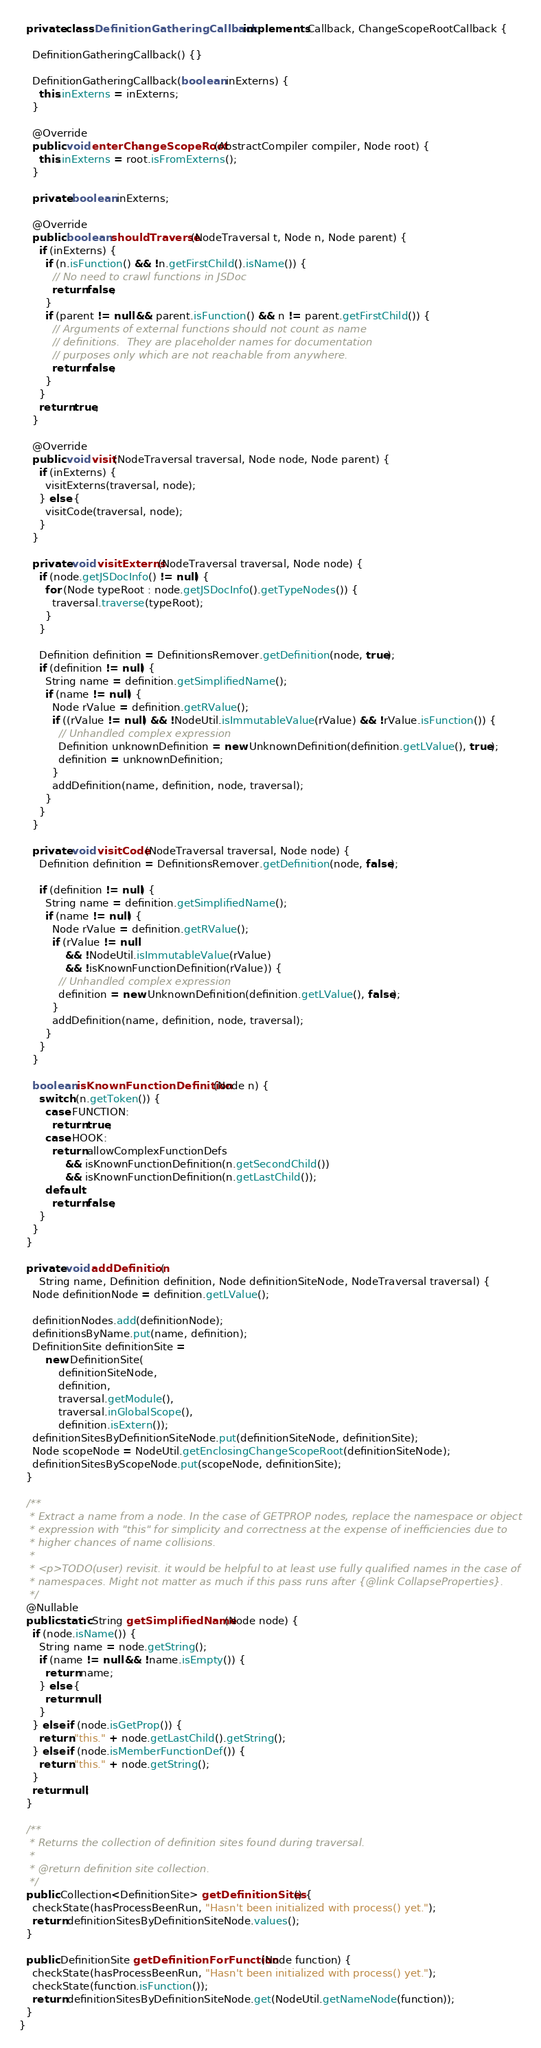Convert code to text. <code><loc_0><loc_0><loc_500><loc_500><_Java_>
  private class DefinitionGatheringCallback implements Callback, ChangeScopeRootCallback {

    DefinitionGatheringCallback() {}

    DefinitionGatheringCallback(boolean inExterns) {
      this.inExterns = inExterns;
    }

    @Override
    public void enterChangeScopeRoot(AbstractCompiler compiler, Node root) {
      this.inExterns = root.isFromExterns();
    }

    private boolean inExterns;

    @Override
    public boolean shouldTraverse(NodeTraversal t, Node n, Node parent) {
      if (inExterns) {
        if (n.isFunction() && !n.getFirstChild().isName()) {
          // No need to crawl functions in JSDoc
          return false;
        }
        if (parent != null && parent.isFunction() && n != parent.getFirstChild()) {
          // Arguments of external functions should not count as name
          // definitions.  They are placeholder names for documentation
          // purposes only which are not reachable from anywhere.
          return false;
        }
      }
      return true;
    }

    @Override
    public void visit(NodeTraversal traversal, Node node, Node parent) {
      if (inExterns) {
        visitExterns(traversal, node);
      } else {
        visitCode(traversal, node);
      }
    }

    private void visitExterns(NodeTraversal traversal, Node node) {
      if (node.getJSDocInfo() != null) {
        for (Node typeRoot : node.getJSDocInfo().getTypeNodes()) {
          traversal.traverse(typeRoot);
        }
      }

      Definition definition = DefinitionsRemover.getDefinition(node, true);
      if (definition != null) {
        String name = definition.getSimplifiedName();
        if (name != null) {
          Node rValue = definition.getRValue();
          if ((rValue != null) && !NodeUtil.isImmutableValue(rValue) && !rValue.isFunction()) {
            // Unhandled complex expression
            Definition unknownDefinition = new UnknownDefinition(definition.getLValue(), true);
            definition = unknownDefinition;
          }
          addDefinition(name, definition, node, traversal);
        }
      }
    }

    private void visitCode(NodeTraversal traversal, Node node) {
      Definition definition = DefinitionsRemover.getDefinition(node, false);

      if (definition != null) {
        String name = definition.getSimplifiedName();
        if (name != null) {
          Node rValue = definition.getRValue();
          if (rValue != null
              && !NodeUtil.isImmutableValue(rValue)
              && !isKnownFunctionDefinition(rValue)) {
            // Unhandled complex expression
            definition = new UnknownDefinition(definition.getLValue(), false);
          }
          addDefinition(name, definition, node, traversal);
        }
      }
    }

    boolean isKnownFunctionDefinition(Node n) {
      switch (n.getToken()) {
        case FUNCTION:
          return true;
        case HOOK:
          return allowComplexFunctionDefs
              && isKnownFunctionDefinition(n.getSecondChild())
              && isKnownFunctionDefinition(n.getLastChild());
        default:
          return false;
      }
    }
  }

  private void addDefinition(
      String name, Definition definition, Node definitionSiteNode, NodeTraversal traversal) {
    Node definitionNode = definition.getLValue();

    definitionNodes.add(definitionNode);
    definitionsByName.put(name, definition);
    DefinitionSite definitionSite =
        new DefinitionSite(
            definitionSiteNode,
            definition,
            traversal.getModule(),
            traversal.inGlobalScope(),
            definition.isExtern());
    definitionSitesByDefinitionSiteNode.put(definitionSiteNode, definitionSite);
    Node scopeNode = NodeUtil.getEnclosingChangeScopeRoot(definitionSiteNode);
    definitionSitesByScopeNode.put(scopeNode, definitionSite);
  }

  /**
   * Extract a name from a node. In the case of GETPROP nodes, replace the namespace or object
   * expression with "this" for simplicity and correctness at the expense of inefficiencies due to
   * higher chances of name collisions.
   *
   * <p>TODO(user) revisit. it would be helpful to at least use fully qualified names in the case of
   * namespaces. Might not matter as much if this pass runs after {@link CollapseProperties}.
   */
  @Nullable
  public static String getSimplifiedName(Node node) {
    if (node.isName()) {
      String name = node.getString();
      if (name != null && !name.isEmpty()) {
        return name;
      } else {
        return null;
      }
    } else if (node.isGetProp()) {
      return "this." + node.getLastChild().getString();
    } else if (node.isMemberFunctionDef()) {
      return "this." + node.getString();
    }
    return null;
  }

  /**
   * Returns the collection of definition sites found during traversal.
   *
   * @return definition site collection.
   */
  public Collection<DefinitionSite> getDefinitionSites() {
    checkState(hasProcessBeenRun, "Hasn't been initialized with process() yet.");
    return definitionSitesByDefinitionSiteNode.values();
  }

  public DefinitionSite getDefinitionForFunction(Node function) {
    checkState(hasProcessBeenRun, "Hasn't been initialized with process() yet.");
    checkState(function.isFunction());
    return definitionSitesByDefinitionSiteNode.get(NodeUtil.getNameNode(function));
  }
}
</code> 